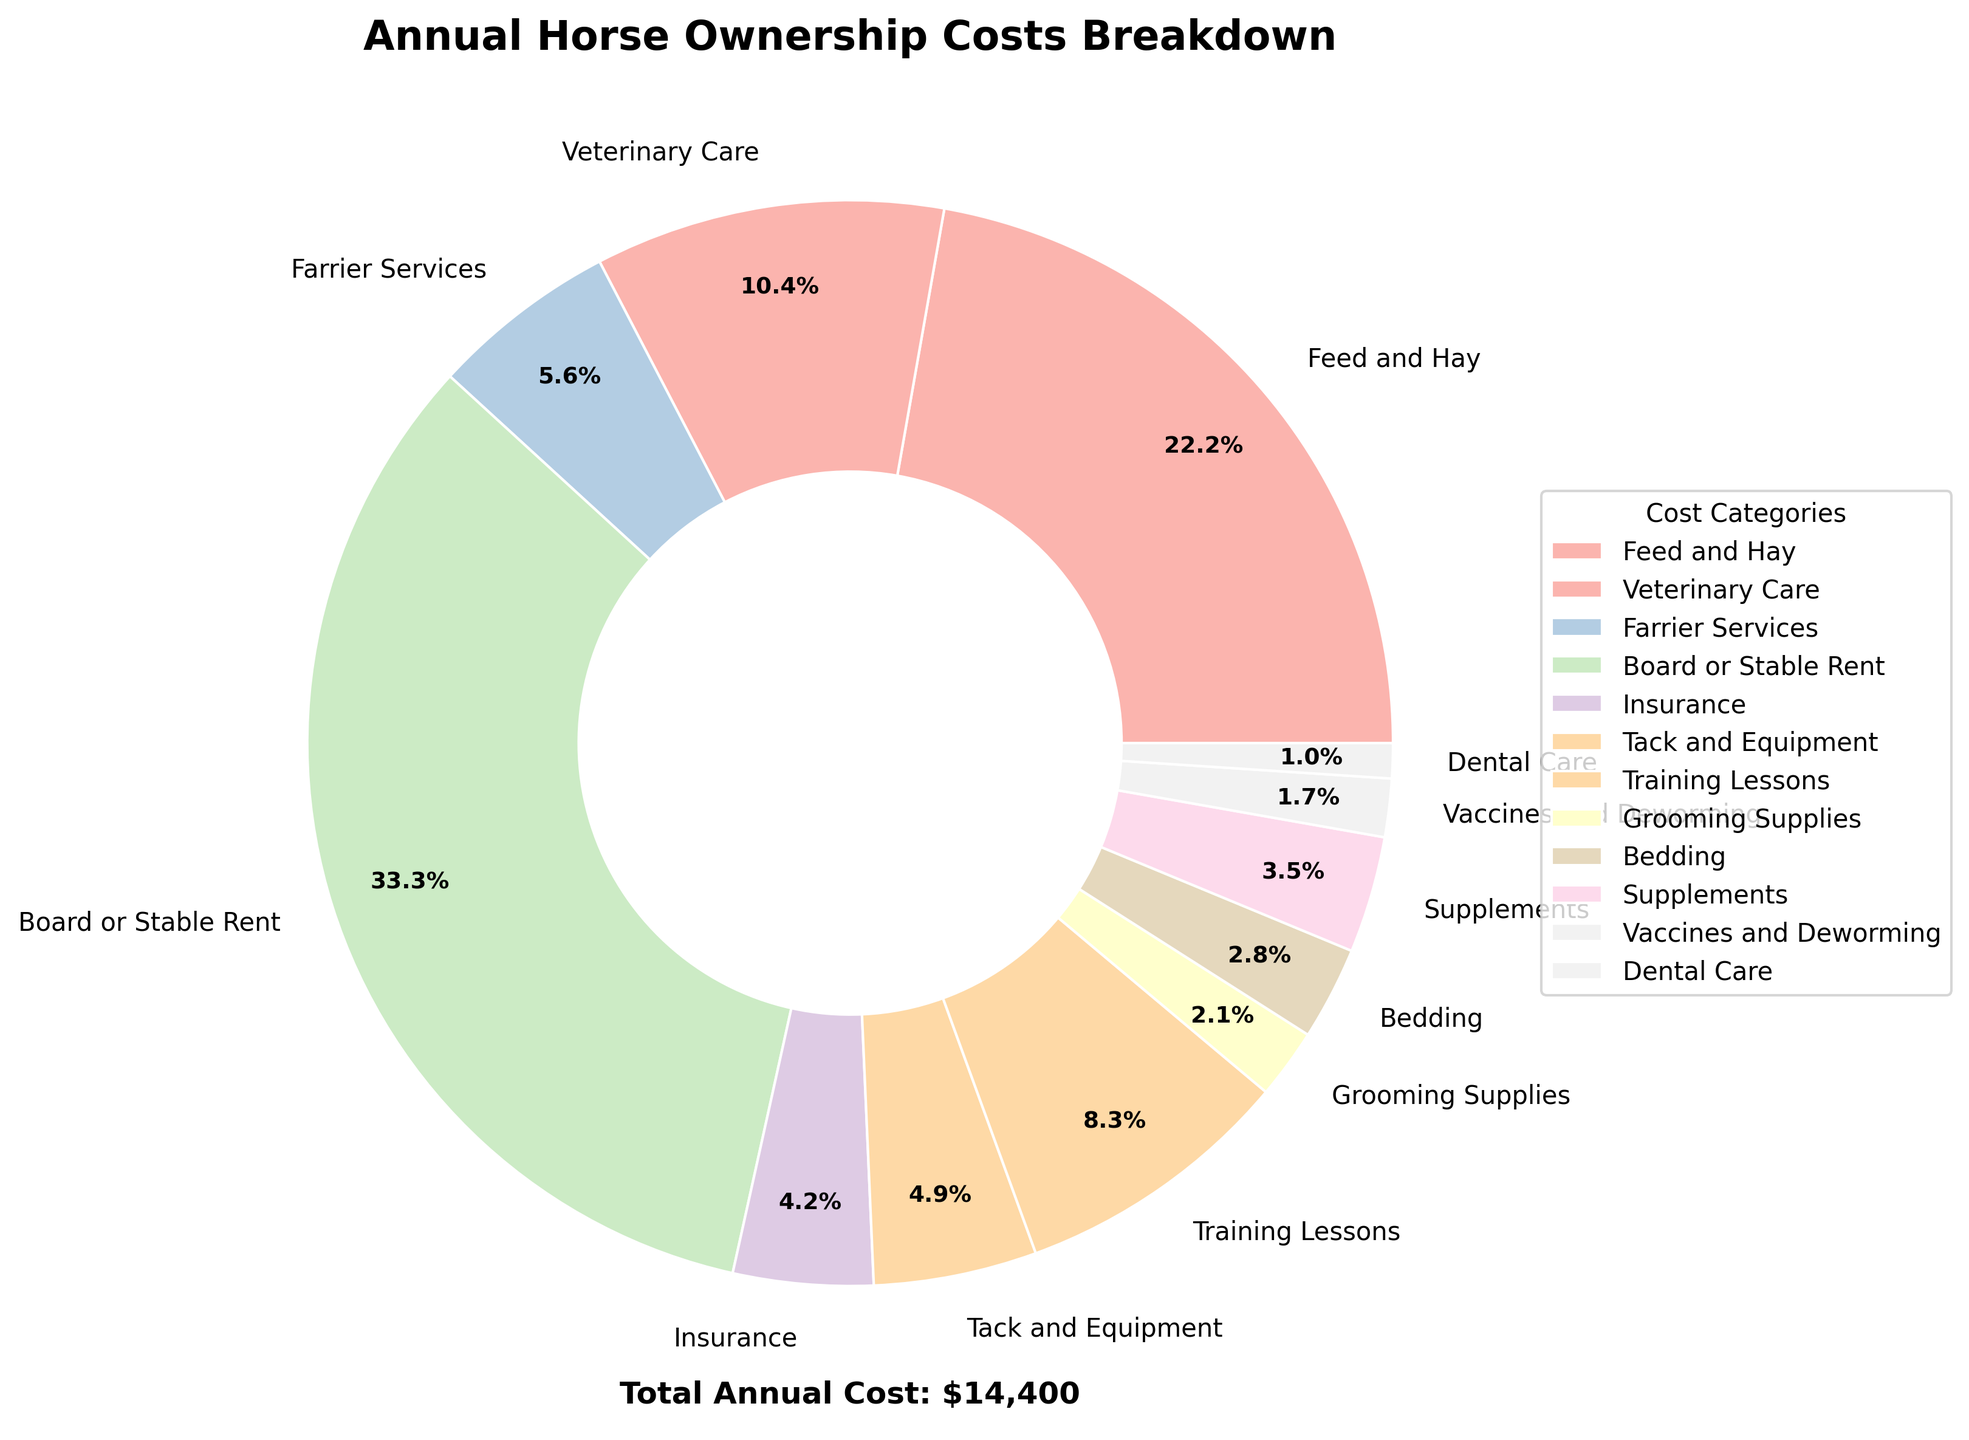Which category has the highest cost? The category with the highest percentage in the pie chart will be the one that has the highest cost.
Answer: Board or Stable Rent How much do Feed and Hay, Veterinary Care, and Farrier Services cost combined? Add up the costs for Feed and Hay ($3200), Veterinary Care ($1500), and Farrier Services ($800). The total is 3200 + 1500 + 800 = $5500.
Answer: $5500 Which category has a lower cost: Supplements or Tack and Equipment? Compare their percentages in the pie chart. Supplements have a lower percentage than Tack and Equipment, indicating a lower cost.
Answer: Supplements What is the percentage of the total cost for Training Lessons? The pie chart segment labeled 'Training Lessons' shows its percentage. Training Lessons account for 1200 of the total cost, translating to approximately 9.6%.
Answer: 9.6% How do the costs of Insurance and Bedding compare? Compare the percentages of Insurance and Bedding in the pie chart. Insurance and Bedding have similar but slightly different percentages, with Insurance costing $600 and Bedding costing $400.
Answer: Insurance is higher What is the total cost of Grooming Supplies and Dental Care combined? Add up the costs for Grooming Supplies ($300) and Dental Care ($150). The total is 300 + 150 = $450.
Answer: $450 What is the percentage difference between the cost of Vaccines and Deworming and Supplements? Find the percentages for both categories in the pie chart. Vaccines and Deworming cost $250, while Supplements cost $500. The difference in cost is 500 - 250 = $250, and the corresponding percentage difference can be calculated based on their totals over the total annual cost.
Answer: Approximately 2% Which three categories contribute the least to the total cost? Identify the three smallest segments in the pie chart. These are Grooming Supplies, Dental Care, and Vaccines and Deworming.
Answer: Grooming Supplies, Dental Care, and Vaccines and Deworming What is the combined percentage of Veterinary Care and Training Lessons? Add up the percentages for Veterinary Care and Training Lessons from the pie chart. Veterinary Care is approximately 12% and Training Lessons is approximately 9.6%. So, the combined percentage is around 12 + 9.6 = 21.6%.
Answer: 21.6% Which category represents approximately 5% of the total cost? Look for the category with a segment that covers around 5% of the pie chart. Bedding costs $400 out of the total, which is a little over 3%, close to 5%.
Answer: Bedding 